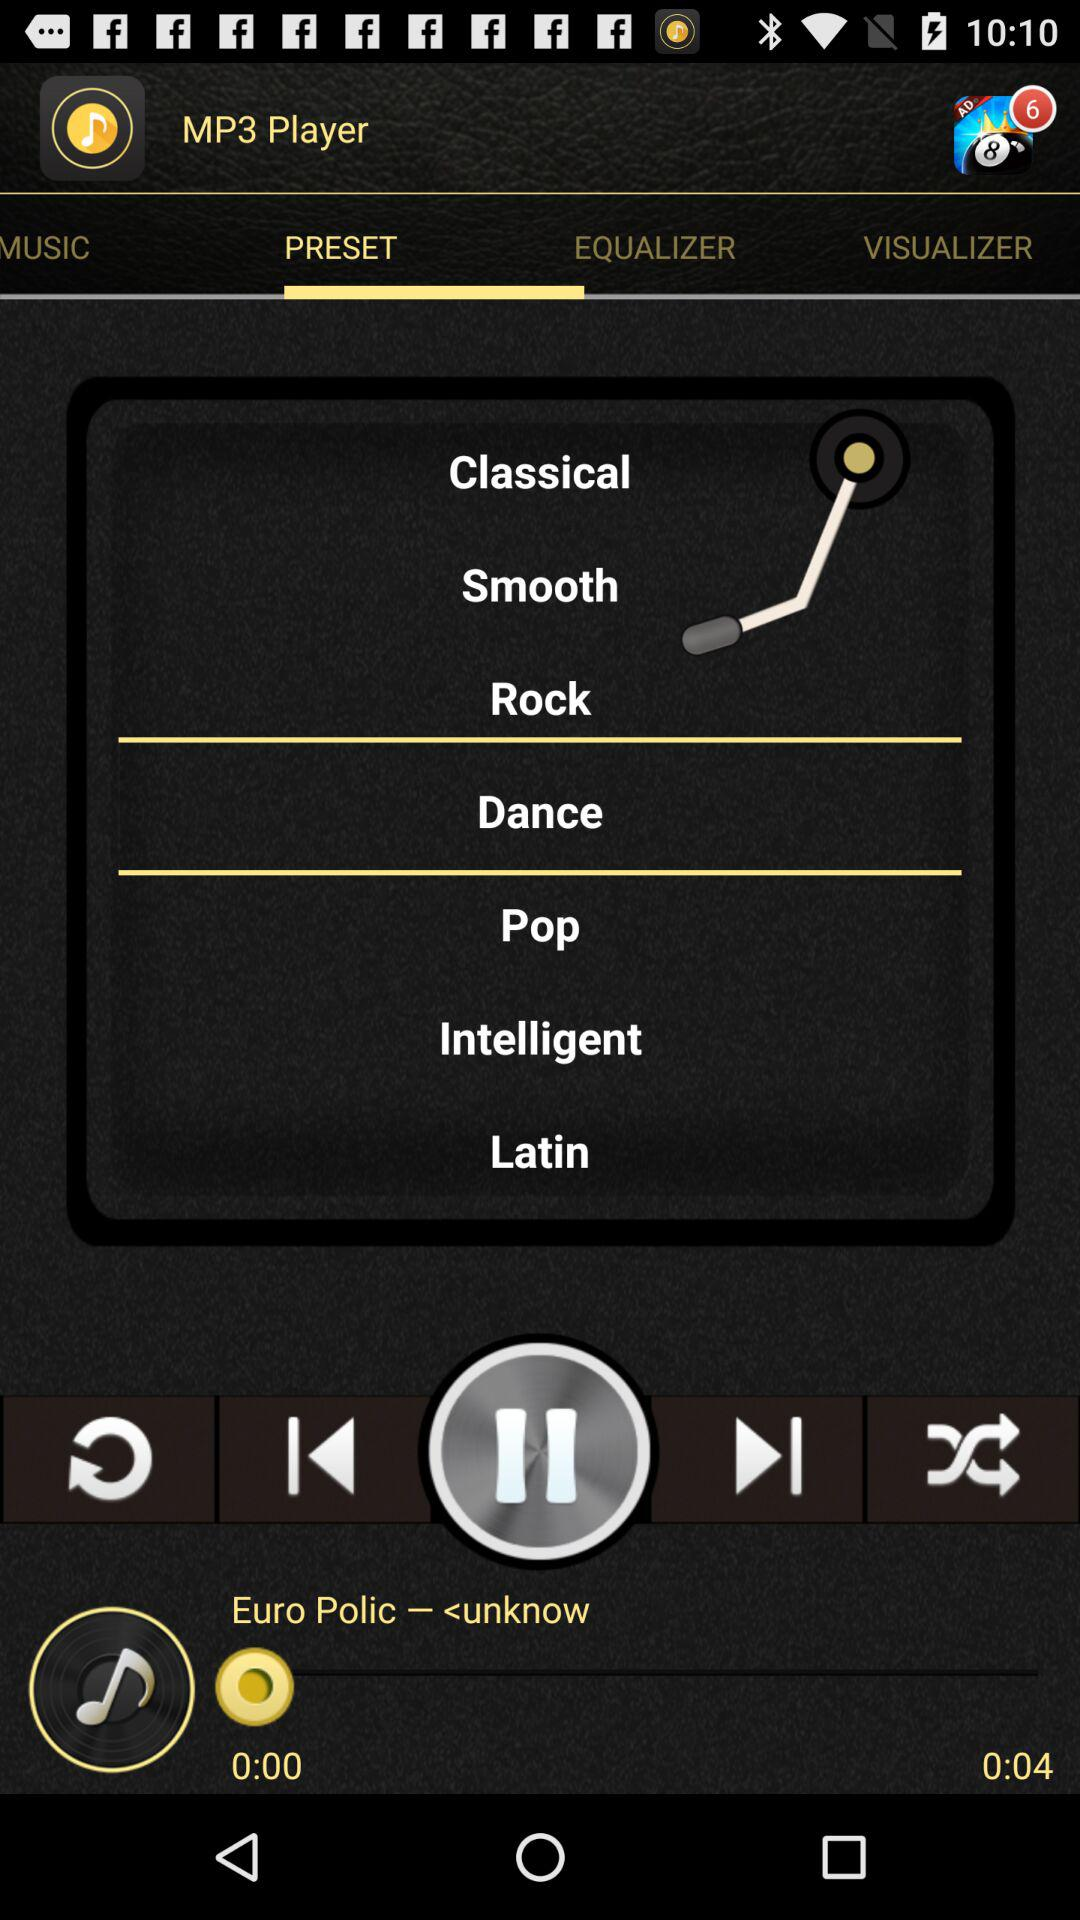What is the duration of the song? The duration of the song is 4 seconds. 